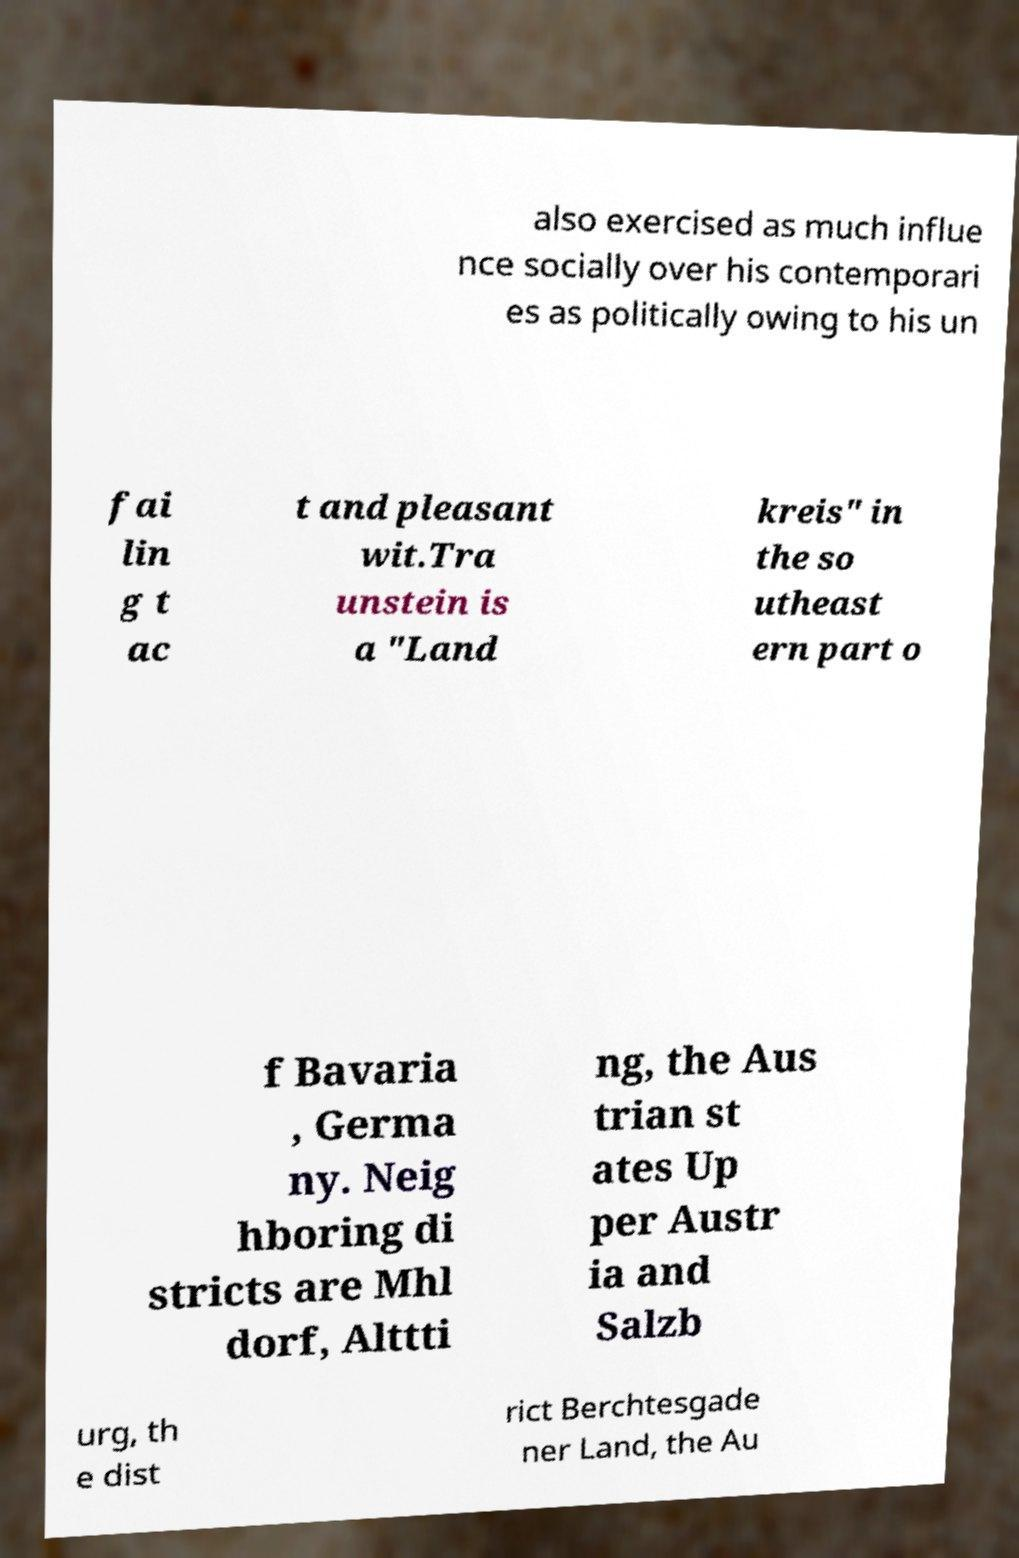Can you read and provide the text displayed in the image?This photo seems to have some interesting text. Can you extract and type it out for me? also exercised as much influe nce socially over his contemporari es as politically owing to his un fai lin g t ac t and pleasant wit.Tra unstein is a "Land kreis" in the so utheast ern part o f Bavaria , Germa ny. Neig hboring di stricts are Mhl dorf, Alttti ng, the Aus trian st ates Up per Austr ia and Salzb urg, th e dist rict Berchtesgade ner Land, the Au 